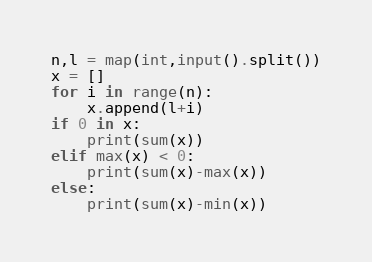<code> <loc_0><loc_0><loc_500><loc_500><_Python_>n,l = map(int,input().split())
x = []
for i in range(n):
    x.append(l+i)
if 0 in x:
    print(sum(x))
elif max(x) < 0:
    print(sum(x)-max(x))
else:
    print(sum(x)-min(x))</code> 